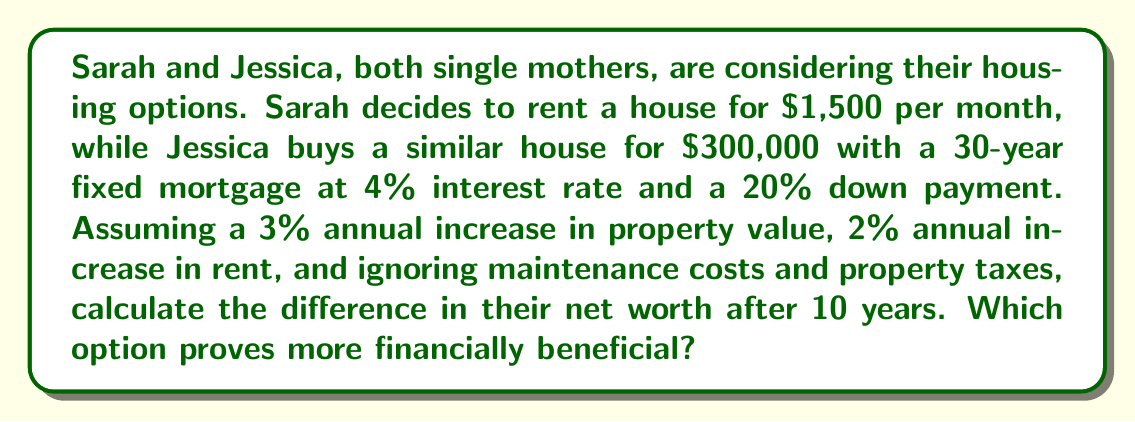Give your solution to this math problem. Let's break this down step-by-step:

1. Jessica's home purchase:
   a) Down payment: $300,000 * 20% = $60,000
   b) Loan amount: $300,000 - $60,000 = $240,000
   c) Monthly mortgage payment:
      $$P = L\frac{r(1+r)^n}{(1+r)^n-1}$$
      Where $P$ is the monthly payment, $L$ is the loan amount, $r$ is the monthly interest rate, and $n$ is the number of payments.
      $$P = 240000 \cdot \frac{0.04/12(1+0.04/12)^{360}}{(1+0.04/12)^{360}-1} \approx $1,145.80$$

   d) Total paid after 10 years: $1,145.80 * 12 * 10 = $137,496

   e) Remaining principal after 10 years:
      $$240000(1+0.04/12)^{120} - \frac{1145.80((1+0.04/12)^{120}-1)}{0.04/12} \approx $193,660.94$$

   f) Home value after 10 years with 3% annual appreciation:
      $$300000(1+0.03)^{10} \approx $403,070.88$$

   Jessica's net worth: $403,070.88 - $193,660.94 = $209,409.94

2. Sarah's renting scenario:
   a) Initial monthly rent: $1,500
   b) Total rent paid over 10 years with 2% annual increase:
      $$\sum_{i=0}^9 1500(1.02)^i * 12 \approx $196,677.97$$

   Sarah's net worth: $0 (assuming all rent is an expense)

3. Difference in net worth:
   Jessica's net worth - Sarah's net worth = $209,409.94 - $0 = $209,409.94
Answer: Buying is more financially beneficial, with a $209,409.94 difference in net worth after 10 years. 